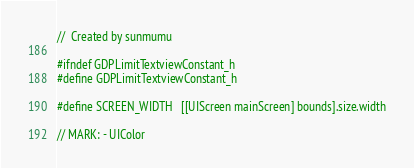<code> <loc_0><loc_0><loc_500><loc_500><_C_>//  Created by sunmumu

#ifndef GDPLimitTextviewConstant_h
#define GDPLimitTextviewConstant_h

#define SCREEN_WIDTH   [[UIScreen mainScreen] bounds].size.width

// MARK: - UIColor</code> 